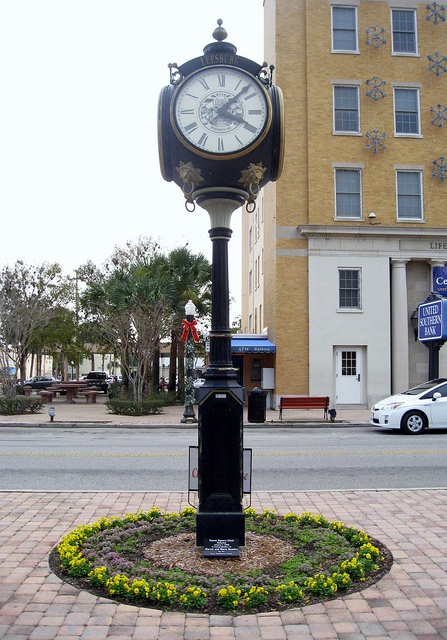Describe the objects in this image and their specific colors. I can see clock in white, lightgray, darkgray, and gray tones, car in white, black, lightblue, and darkgray tones, bench in white, maroon, black, gray, and brown tones, car in white, black, gray, and darkgray tones, and car in white, black, gray, lightgray, and darkgray tones in this image. 